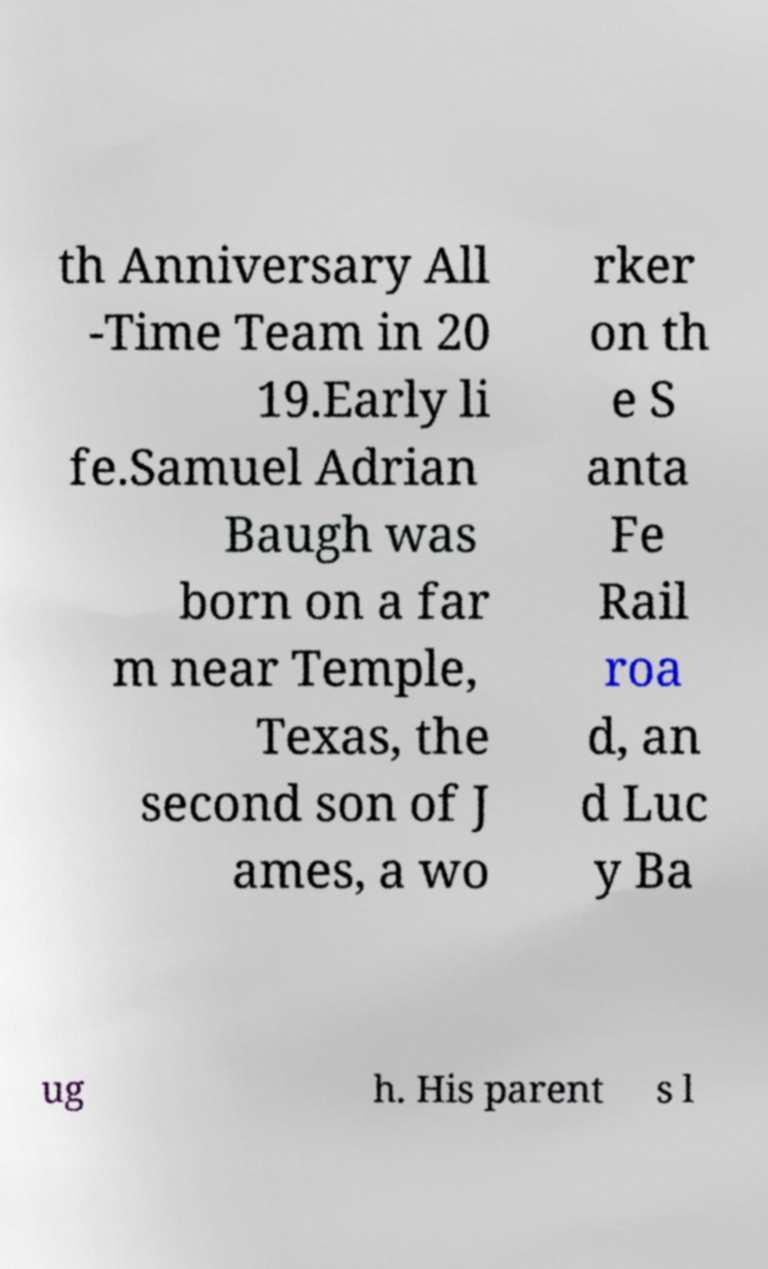Could you extract and type out the text from this image? th Anniversary All -Time Team in 20 19.Early li fe.Samuel Adrian Baugh was born on a far m near Temple, Texas, the second son of J ames, a wo rker on th e S anta Fe Rail roa d, an d Luc y Ba ug h. His parent s l 